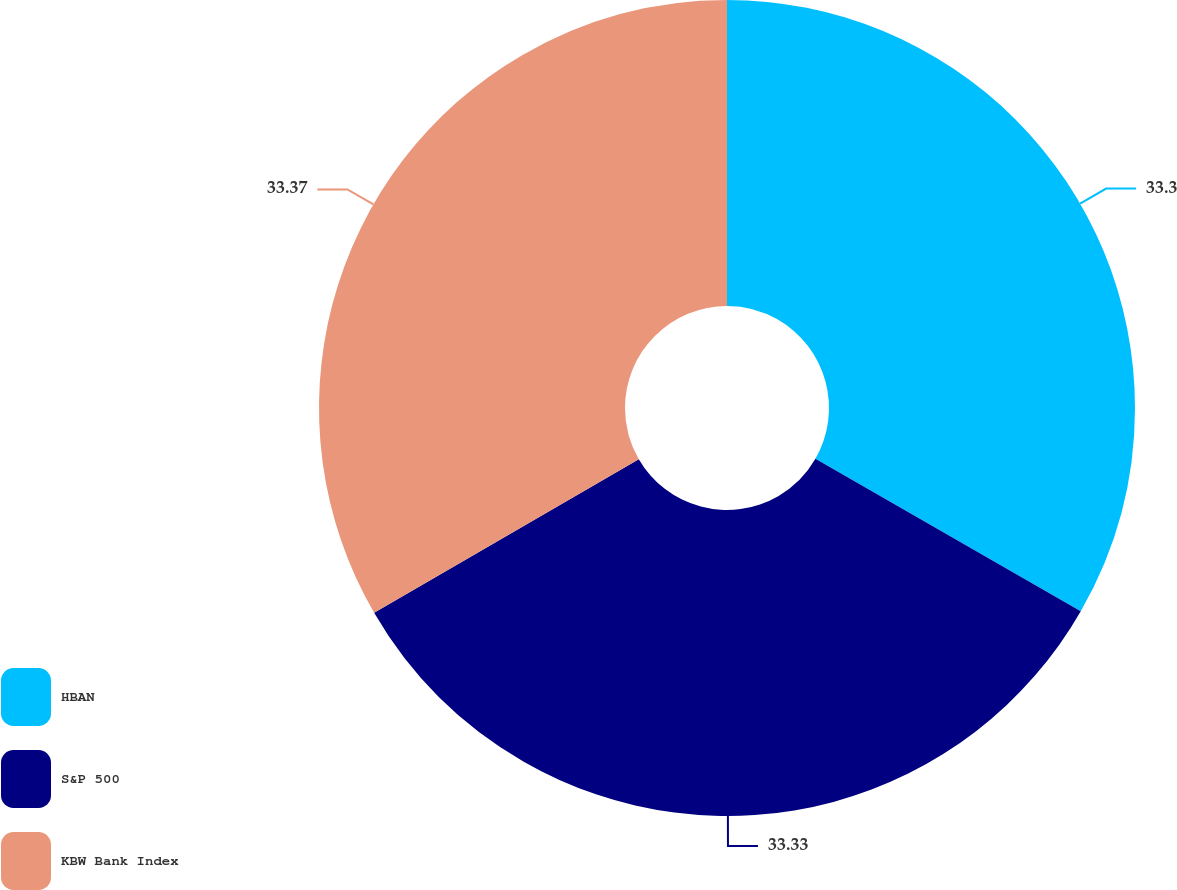Convert chart. <chart><loc_0><loc_0><loc_500><loc_500><pie_chart><fcel>HBAN<fcel>S&P 500<fcel>KBW Bank Index<nl><fcel>33.3%<fcel>33.33%<fcel>33.37%<nl></chart> 